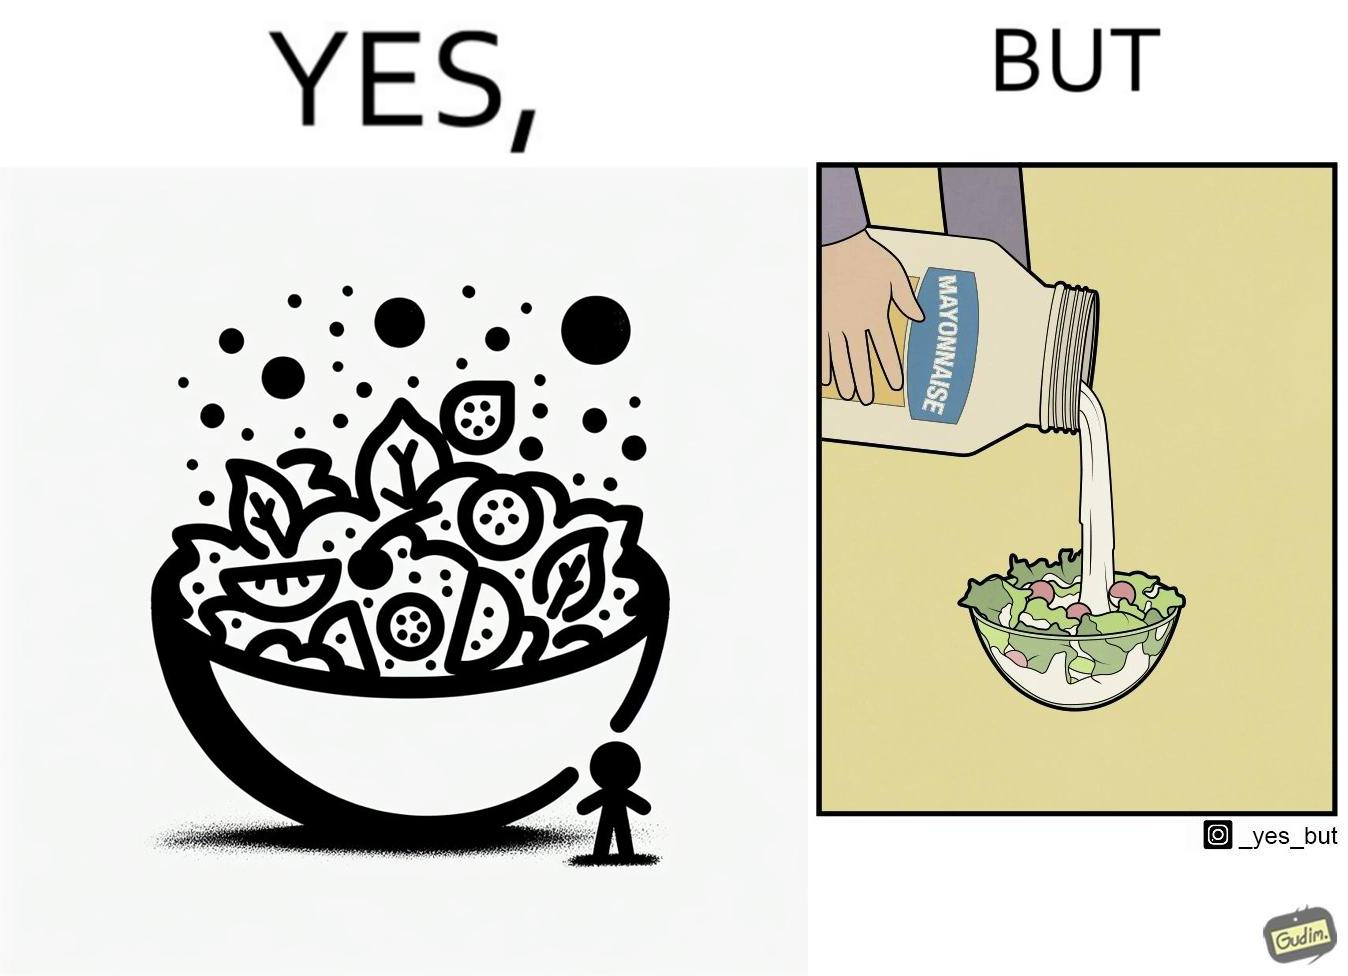Describe the contrast between the left and right parts of this image. In the left part of the image: salad in a bowl In the right part of the image: pouring mayonnaise sauce on salad in a bowl 